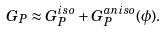Convert formula to latex. <formula><loc_0><loc_0><loc_500><loc_500>G _ { P } \approx G _ { P } ^ { i s o } + G _ { P } ^ { a n i s o } ( \phi ) .</formula> 